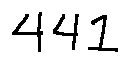<formula> <loc_0><loc_0><loc_500><loc_500>4 4 1</formula> 